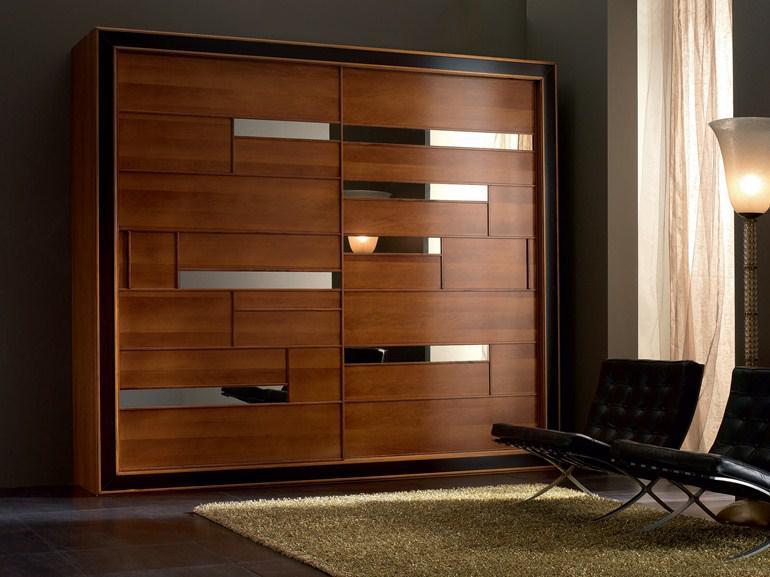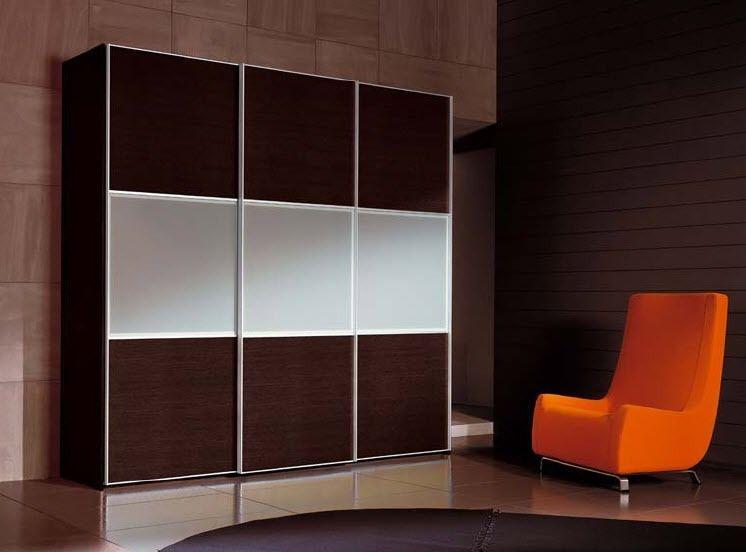The first image is the image on the left, the second image is the image on the right. Evaluate the accuracy of this statement regarding the images: "One image shows a sliding door wardrobe that sits against a wall and has two dark wood sections and one section that is not dark.". Is it true? Answer yes or no. Yes. The first image is the image on the left, the second image is the image on the right. For the images shown, is this caption "In at least one image there is a single hanging wooden door." true? Answer yes or no. No. 